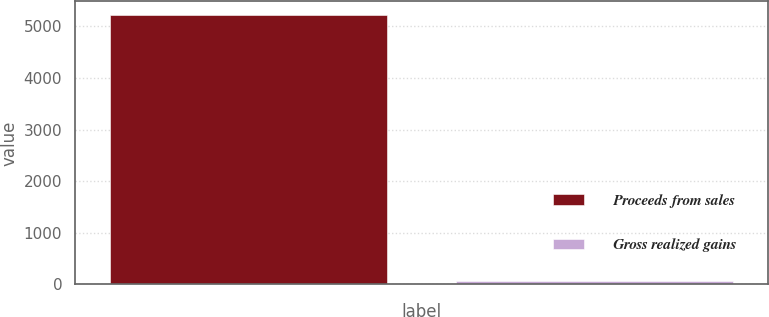<chart> <loc_0><loc_0><loc_500><loc_500><bar_chart><fcel>Proceeds from sales<fcel>Gross realized gains<nl><fcel>5224<fcel>75<nl></chart> 